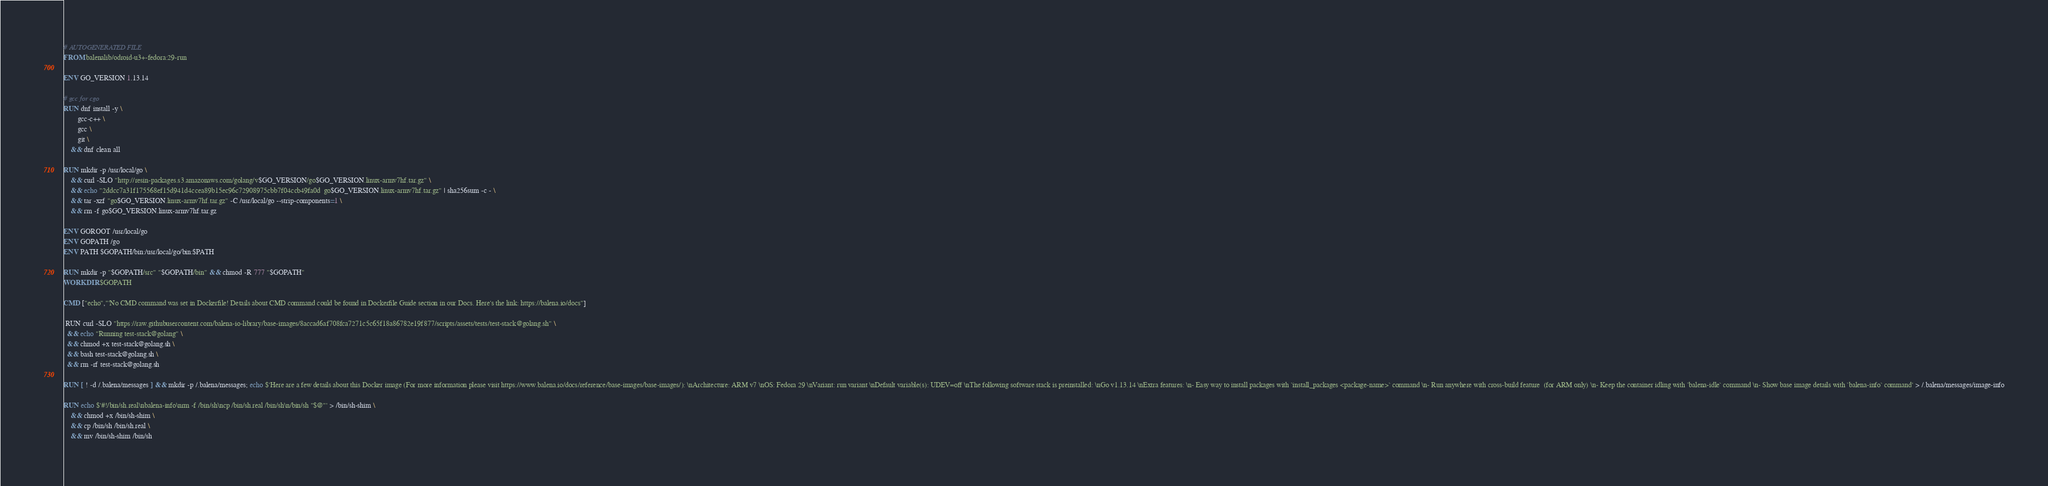<code> <loc_0><loc_0><loc_500><loc_500><_Dockerfile_># AUTOGENERATED FILE
FROM balenalib/odroid-u3+-fedora:29-run

ENV GO_VERSION 1.13.14

# gcc for cgo
RUN dnf install -y \
		gcc-c++ \
		gcc \
		git \
	&& dnf clean all

RUN mkdir -p /usr/local/go \
	&& curl -SLO "http://resin-packages.s3.amazonaws.com/golang/v$GO_VERSION/go$GO_VERSION.linux-armv7hf.tar.gz" \
	&& echo "2ddcc7a31f175568ef15d941d4ccea89b15ec96c72908975cbb7f04ccb49fa0d  go$GO_VERSION.linux-armv7hf.tar.gz" | sha256sum -c - \
	&& tar -xzf "go$GO_VERSION.linux-armv7hf.tar.gz" -C /usr/local/go --strip-components=1 \
	&& rm -f go$GO_VERSION.linux-armv7hf.tar.gz

ENV GOROOT /usr/local/go
ENV GOPATH /go
ENV PATH $GOPATH/bin:/usr/local/go/bin:$PATH

RUN mkdir -p "$GOPATH/src" "$GOPATH/bin" && chmod -R 777 "$GOPATH"
WORKDIR $GOPATH

CMD ["echo","'No CMD command was set in Dockerfile! Details about CMD command could be found in Dockerfile Guide section in our Docs. Here's the link: https://balena.io/docs"]

 RUN curl -SLO "https://raw.githubusercontent.com/balena-io-library/base-images/8accad6af708fca7271c5c65f18a86782e19f877/scripts/assets/tests/test-stack@golang.sh" \
  && echo "Running test-stack@golang" \
  && chmod +x test-stack@golang.sh \
  && bash test-stack@golang.sh \
  && rm -rf test-stack@golang.sh 

RUN [ ! -d /.balena/messages ] && mkdir -p /.balena/messages; echo $'Here are a few details about this Docker image (For more information please visit https://www.balena.io/docs/reference/base-images/base-images/): \nArchitecture: ARM v7 \nOS: Fedora 29 \nVariant: run variant \nDefault variable(s): UDEV=off \nThe following software stack is preinstalled: \nGo v1.13.14 \nExtra features: \n- Easy way to install packages with `install_packages <package-name>` command \n- Run anywhere with cross-build feature  (for ARM only) \n- Keep the container idling with `balena-idle` command \n- Show base image details with `balena-info` command' > /.balena/messages/image-info

RUN echo $'#!/bin/sh.real\nbalena-info\nrm -f /bin/sh\ncp /bin/sh.real /bin/sh\n/bin/sh "$@"' > /bin/sh-shim \
	&& chmod +x /bin/sh-shim \
	&& cp /bin/sh /bin/sh.real \
	&& mv /bin/sh-shim /bin/sh</code> 